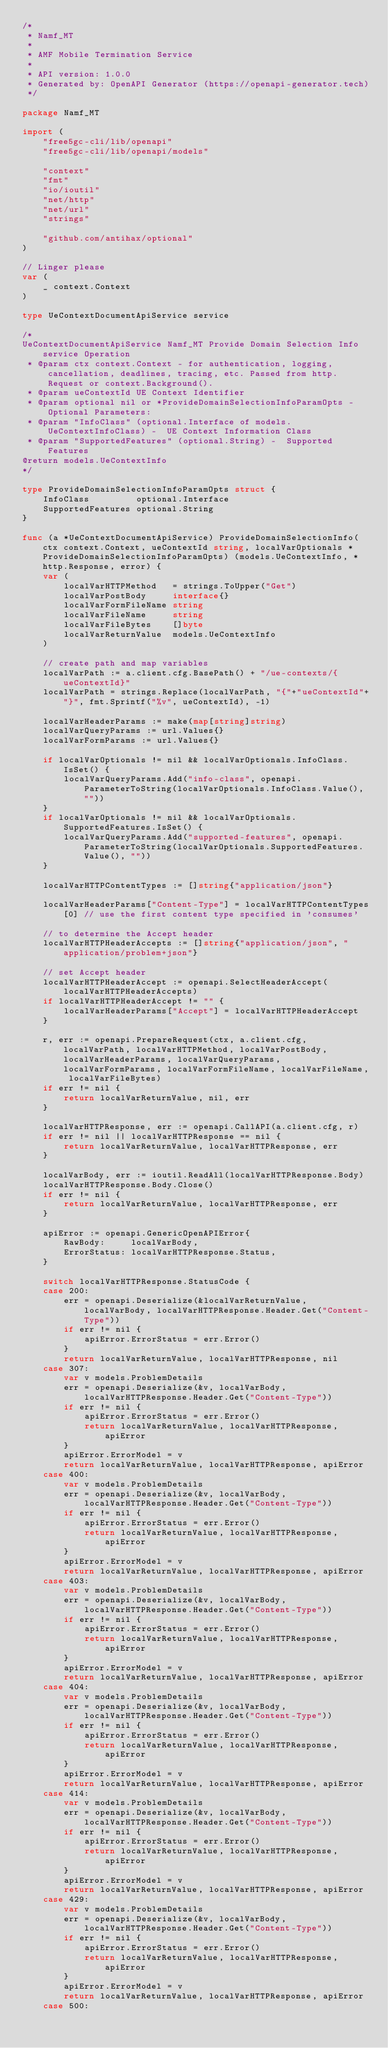Convert code to text. <code><loc_0><loc_0><loc_500><loc_500><_Go_>/*
 * Namf_MT
 *
 * AMF Mobile Termination Service
 *
 * API version: 1.0.0
 * Generated by: OpenAPI Generator (https://openapi-generator.tech)
 */

package Namf_MT

import (
	"free5gc-cli/lib/openapi"
	"free5gc-cli/lib/openapi/models"

	"context"
	"fmt"
	"io/ioutil"
	"net/http"
	"net/url"
	"strings"

	"github.com/antihax/optional"
)

// Linger please
var (
	_ context.Context
)

type UeContextDocumentApiService service

/*
UeContextDocumentApiService Namf_MT Provide Domain Selection Info service Operation
 * @param ctx context.Context - for authentication, logging, cancellation, deadlines, tracing, etc. Passed from http.Request or context.Background().
 * @param ueContextId UE Context Identifier
 * @param optional nil or *ProvideDomainSelectionInfoParamOpts - Optional Parameters:
 * @param "InfoClass" (optional.Interface of models.UeContextInfoClass) -  UE Context Information Class
 * @param "SupportedFeatures" (optional.String) -  Supported Features
@return models.UeContextInfo
*/

type ProvideDomainSelectionInfoParamOpts struct {
	InfoClass         optional.Interface
	SupportedFeatures optional.String
}

func (a *UeContextDocumentApiService) ProvideDomainSelectionInfo(ctx context.Context, ueContextId string, localVarOptionals *ProvideDomainSelectionInfoParamOpts) (models.UeContextInfo, *http.Response, error) {
	var (
		localVarHTTPMethod   = strings.ToUpper("Get")
		localVarPostBody     interface{}
		localVarFormFileName string
		localVarFileName     string
		localVarFileBytes    []byte
		localVarReturnValue  models.UeContextInfo
	)

	// create path and map variables
	localVarPath := a.client.cfg.BasePath() + "/ue-contexts/{ueContextId}"
	localVarPath = strings.Replace(localVarPath, "{"+"ueContextId"+"}", fmt.Sprintf("%v", ueContextId), -1)

	localVarHeaderParams := make(map[string]string)
	localVarQueryParams := url.Values{}
	localVarFormParams := url.Values{}

	if localVarOptionals != nil && localVarOptionals.InfoClass.IsSet() {
		localVarQueryParams.Add("info-class", openapi.ParameterToString(localVarOptionals.InfoClass.Value(), ""))
	}
	if localVarOptionals != nil && localVarOptionals.SupportedFeatures.IsSet() {
		localVarQueryParams.Add("supported-features", openapi.ParameterToString(localVarOptionals.SupportedFeatures.Value(), ""))
	}

	localVarHTTPContentTypes := []string{"application/json"}

	localVarHeaderParams["Content-Type"] = localVarHTTPContentTypes[0] // use the first content type specified in 'consumes'

	// to determine the Accept header
	localVarHTTPHeaderAccepts := []string{"application/json", "application/problem+json"}

	// set Accept header
	localVarHTTPHeaderAccept := openapi.SelectHeaderAccept(localVarHTTPHeaderAccepts)
	if localVarHTTPHeaderAccept != "" {
		localVarHeaderParams["Accept"] = localVarHTTPHeaderAccept
	}

	r, err := openapi.PrepareRequest(ctx, a.client.cfg, localVarPath, localVarHTTPMethod, localVarPostBody, localVarHeaderParams, localVarQueryParams, localVarFormParams, localVarFormFileName, localVarFileName, localVarFileBytes)
	if err != nil {
		return localVarReturnValue, nil, err
	}

	localVarHTTPResponse, err := openapi.CallAPI(a.client.cfg, r)
	if err != nil || localVarHTTPResponse == nil {
		return localVarReturnValue, localVarHTTPResponse, err
	}

	localVarBody, err := ioutil.ReadAll(localVarHTTPResponse.Body)
	localVarHTTPResponse.Body.Close()
	if err != nil {
		return localVarReturnValue, localVarHTTPResponse, err
	}

	apiError := openapi.GenericOpenAPIError{
		RawBody:     localVarBody,
		ErrorStatus: localVarHTTPResponse.Status,
	}

	switch localVarHTTPResponse.StatusCode {
	case 200:
		err = openapi.Deserialize(&localVarReturnValue, localVarBody, localVarHTTPResponse.Header.Get("Content-Type"))
		if err != nil {
			apiError.ErrorStatus = err.Error()
		}
		return localVarReturnValue, localVarHTTPResponse, nil
	case 307:
		var v models.ProblemDetails
		err = openapi.Deserialize(&v, localVarBody, localVarHTTPResponse.Header.Get("Content-Type"))
		if err != nil {
			apiError.ErrorStatus = err.Error()
			return localVarReturnValue, localVarHTTPResponse, apiError
		}
		apiError.ErrorModel = v
		return localVarReturnValue, localVarHTTPResponse, apiError
	case 400:
		var v models.ProblemDetails
		err = openapi.Deserialize(&v, localVarBody, localVarHTTPResponse.Header.Get("Content-Type"))
		if err != nil {
			apiError.ErrorStatus = err.Error()
			return localVarReturnValue, localVarHTTPResponse, apiError
		}
		apiError.ErrorModel = v
		return localVarReturnValue, localVarHTTPResponse, apiError
	case 403:
		var v models.ProblemDetails
		err = openapi.Deserialize(&v, localVarBody, localVarHTTPResponse.Header.Get("Content-Type"))
		if err != nil {
			apiError.ErrorStatus = err.Error()
			return localVarReturnValue, localVarHTTPResponse, apiError
		}
		apiError.ErrorModel = v
		return localVarReturnValue, localVarHTTPResponse, apiError
	case 404:
		var v models.ProblemDetails
		err = openapi.Deserialize(&v, localVarBody, localVarHTTPResponse.Header.Get("Content-Type"))
		if err != nil {
			apiError.ErrorStatus = err.Error()
			return localVarReturnValue, localVarHTTPResponse, apiError
		}
		apiError.ErrorModel = v
		return localVarReturnValue, localVarHTTPResponse, apiError
	case 414:
		var v models.ProblemDetails
		err = openapi.Deserialize(&v, localVarBody, localVarHTTPResponse.Header.Get("Content-Type"))
		if err != nil {
			apiError.ErrorStatus = err.Error()
			return localVarReturnValue, localVarHTTPResponse, apiError
		}
		apiError.ErrorModel = v
		return localVarReturnValue, localVarHTTPResponse, apiError
	case 429:
		var v models.ProblemDetails
		err = openapi.Deserialize(&v, localVarBody, localVarHTTPResponse.Header.Get("Content-Type"))
		if err != nil {
			apiError.ErrorStatus = err.Error()
			return localVarReturnValue, localVarHTTPResponse, apiError
		}
		apiError.ErrorModel = v
		return localVarReturnValue, localVarHTTPResponse, apiError
	case 500:</code> 